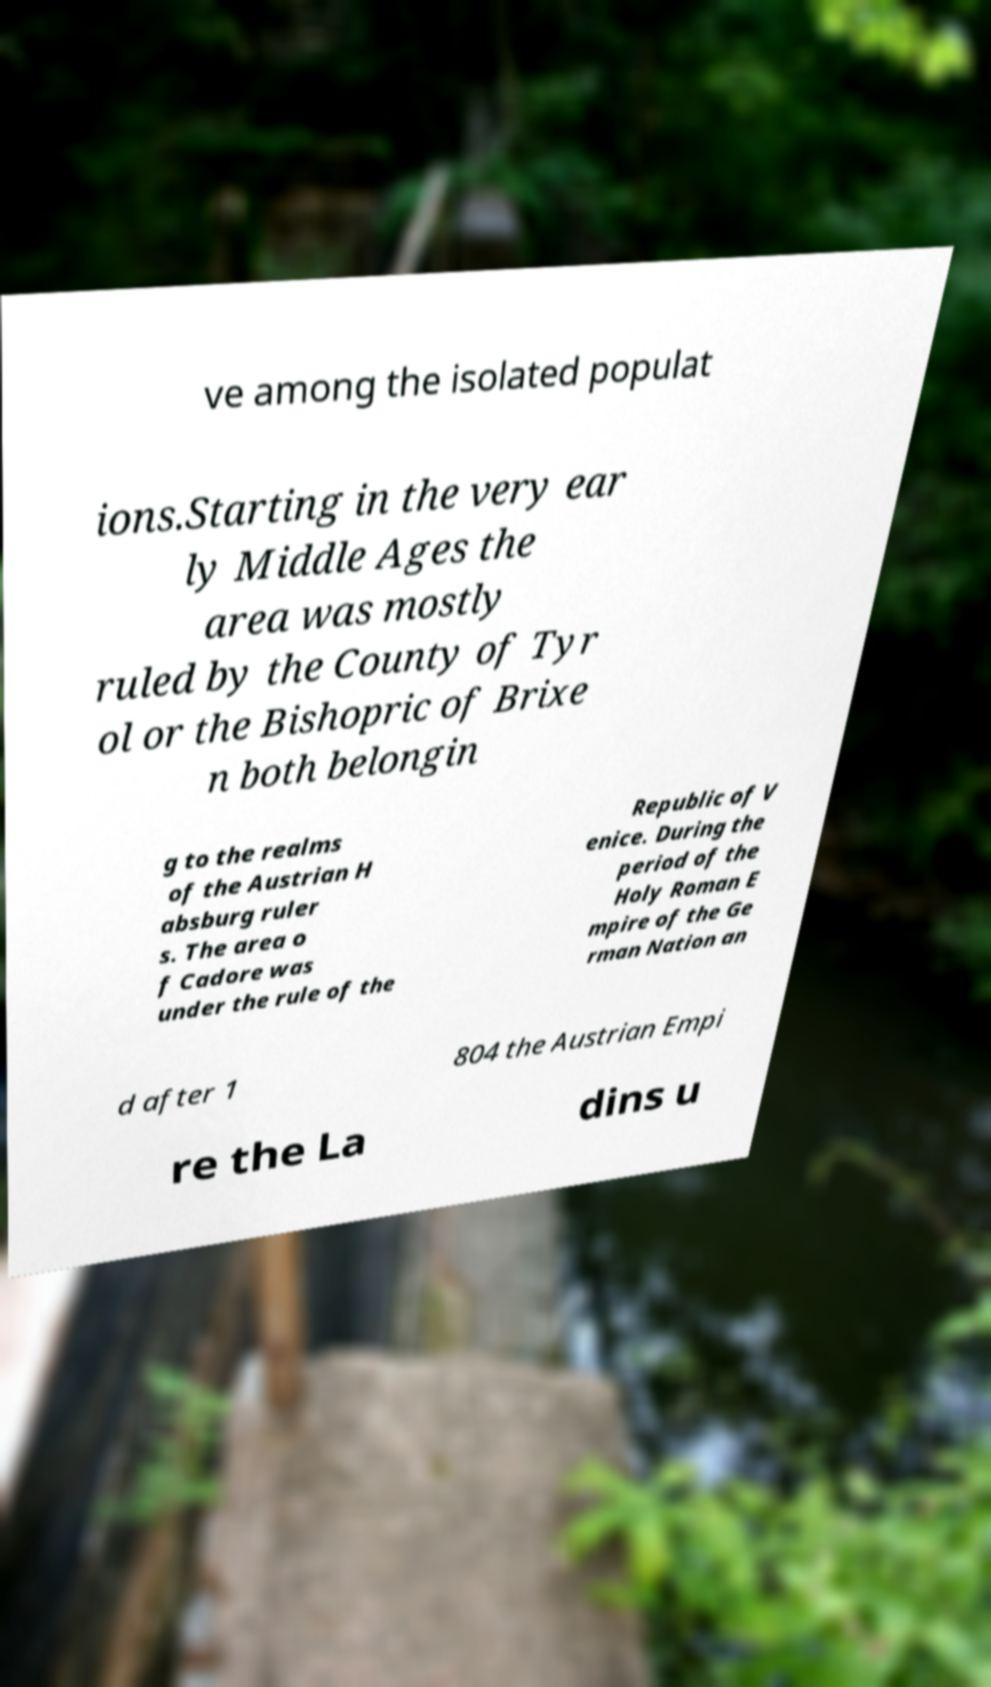I need the written content from this picture converted into text. Can you do that? ve among the isolated populat ions.Starting in the very ear ly Middle Ages the area was mostly ruled by the County of Tyr ol or the Bishopric of Brixe n both belongin g to the realms of the Austrian H absburg ruler s. The area o f Cadore was under the rule of the Republic of V enice. During the period of the Holy Roman E mpire of the Ge rman Nation an d after 1 804 the Austrian Empi re the La dins u 